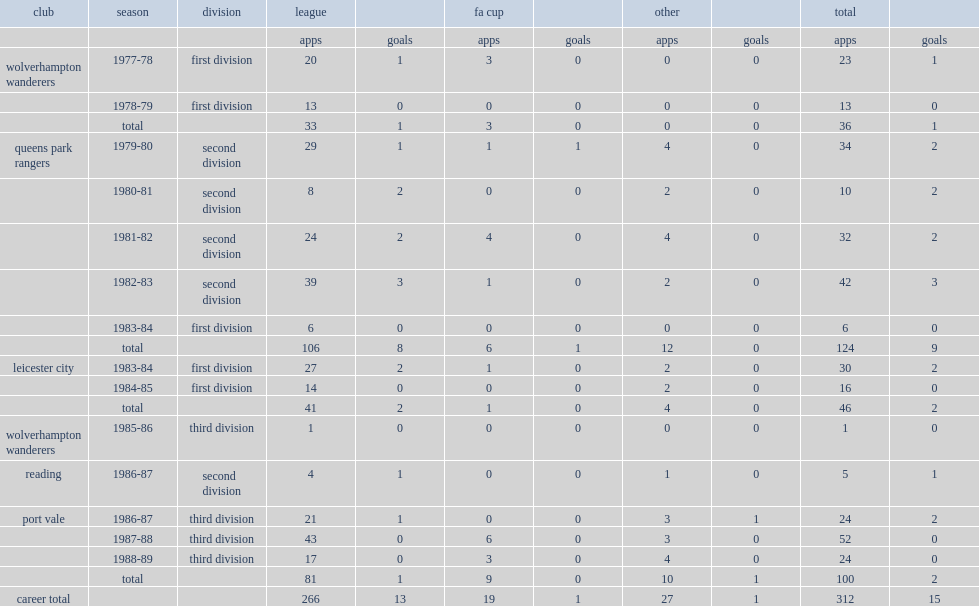Which division did hazell transfer to city of the 1983-84 campaign? First division. 